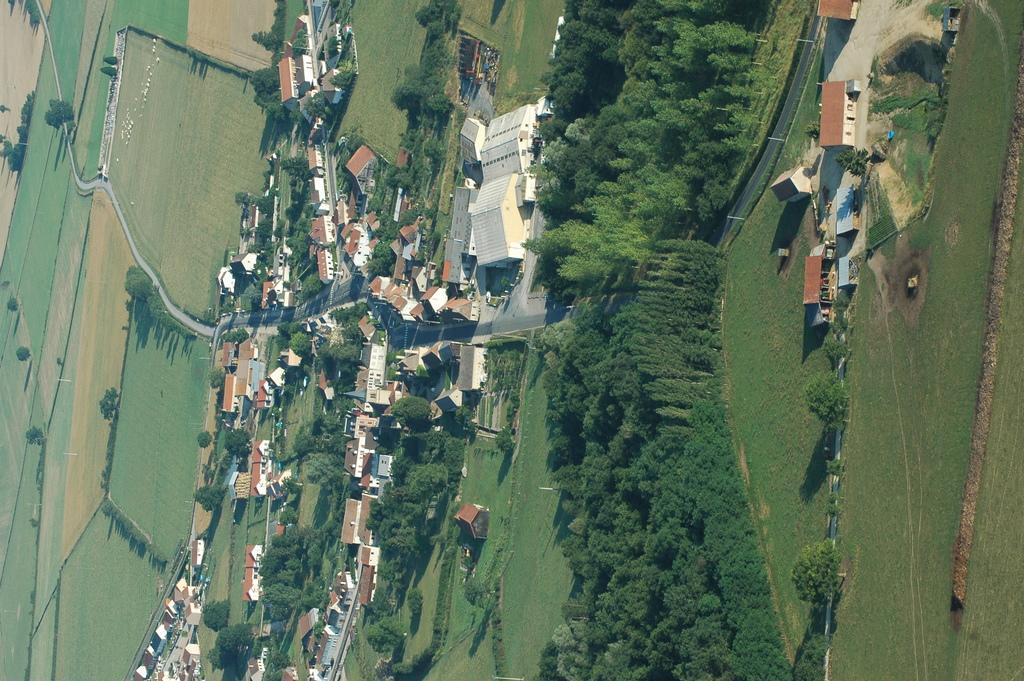Describe this image in one or two sentences. This is the aerial view of a city. In this image we can see ground, trees, roads, buildings and water. 